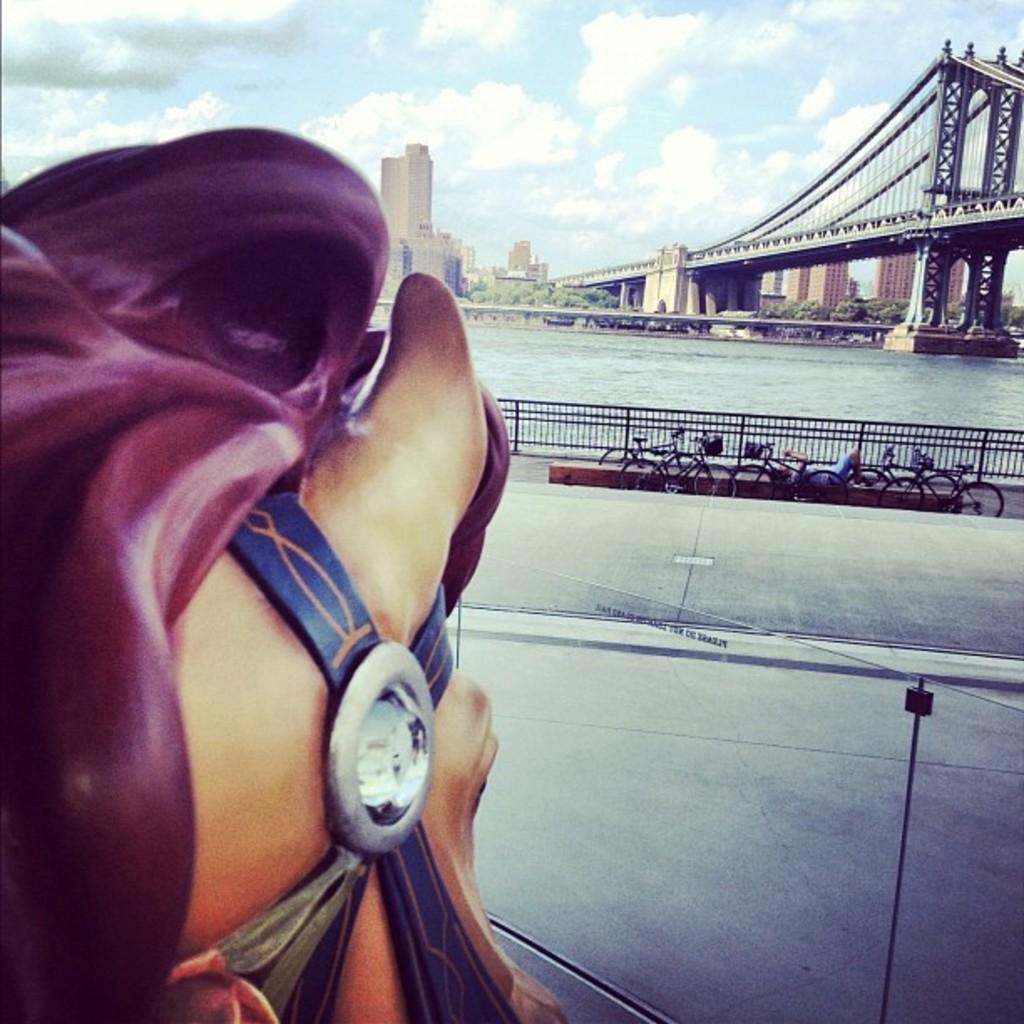What type of vehicles are in the image? There are bicycles in the image. What is separating the bicycles from the road? There is a fence in the image. What surface can be seen in the image for transportation? There is a road in the image. What is present in the image that is used for crossing water? There is a bridge in the image. What type of vegetation is visible in the image? There are trees in the image. What type of structures are visible in the image? There are buildings in the image. What can be seen in the background of the image? The sky with clouds is visible in the background of the image. What flavor of sidewalk can be seen in the image? There is no sidewalk present in the image, and therefore no flavor can be associated with it. What type of feast is being prepared on the bridge in the image? There is no feast being prepared on the bridge in the image; it is a structure for crossing water. 